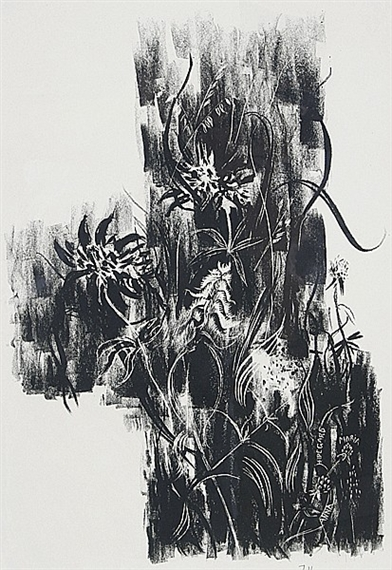What emotions do you think the artist intended to evoke with these dynamic lines and dark colors? The artist may have intended to evoke feelings of turmoil and intensity with the use of dynamic, almost chaotic lines and the stark use of monochrome. The black background offers a sense of depth and perhaps even a bit of melancholy, while the energetic white strokes could convey a burst of light or hope, contrasting the darkness. This dynamic could be seen as a metaphor for personal or societal struggles, expressing a powerful emotional journey through visual elements. 